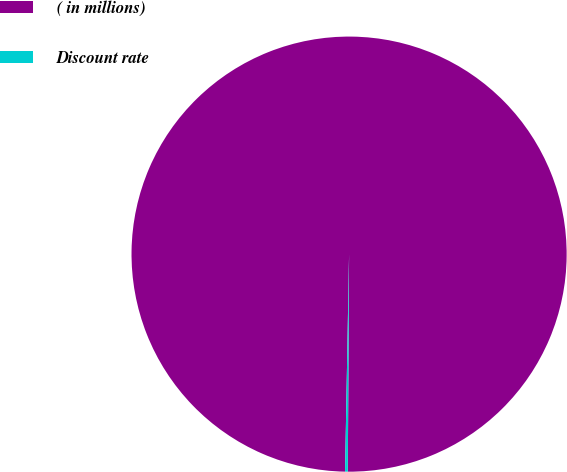Convert chart to OTSL. <chart><loc_0><loc_0><loc_500><loc_500><pie_chart><fcel>( in millions)<fcel>Discount rate<nl><fcel>99.8%<fcel>0.2%<nl></chart> 